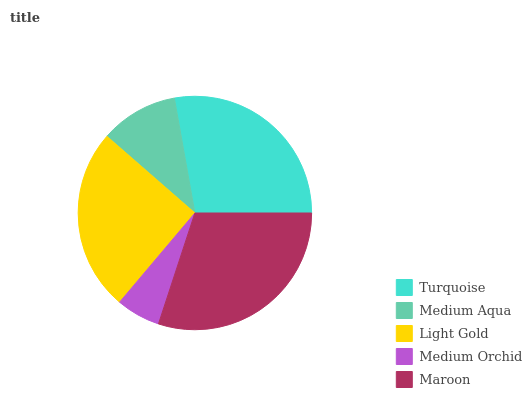Is Medium Orchid the minimum?
Answer yes or no. Yes. Is Maroon the maximum?
Answer yes or no. Yes. Is Medium Aqua the minimum?
Answer yes or no. No. Is Medium Aqua the maximum?
Answer yes or no. No. Is Turquoise greater than Medium Aqua?
Answer yes or no. Yes. Is Medium Aqua less than Turquoise?
Answer yes or no. Yes. Is Medium Aqua greater than Turquoise?
Answer yes or no. No. Is Turquoise less than Medium Aqua?
Answer yes or no. No. Is Light Gold the high median?
Answer yes or no. Yes. Is Light Gold the low median?
Answer yes or no. Yes. Is Medium Aqua the high median?
Answer yes or no. No. Is Turquoise the low median?
Answer yes or no. No. 